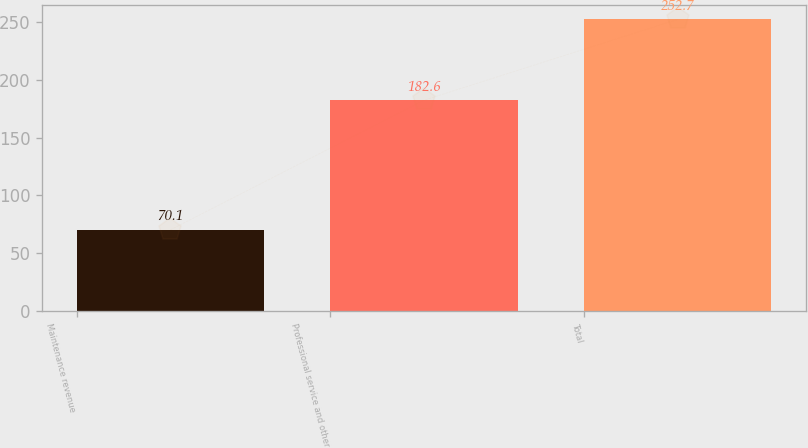Convert chart to OTSL. <chart><loc_0><loc_0><loc_500><loc_500><bar_chart><fcel>Maintenance revenue<fcel>Professional service and other<fcel>Total<nl><fcel>70.1<fcel>182.6<fcel>252.7<nl></chart> 